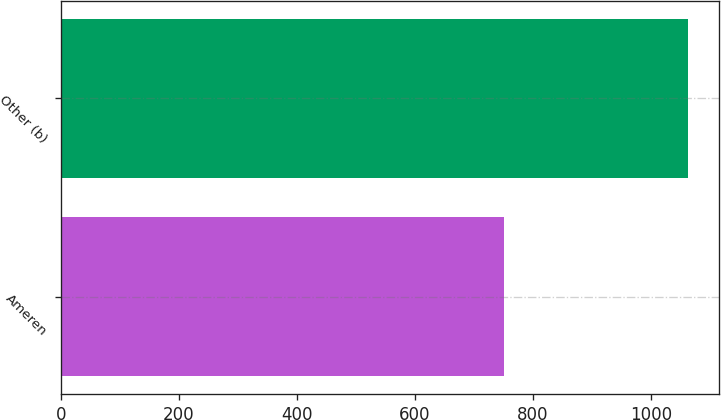<chart> <loc_0><loc_0><loc_500><loc_500><bar_chart><fcel>Ameren<fcel>Other (b)<nl><fcel>750<fcel>1062<nl></chart> 